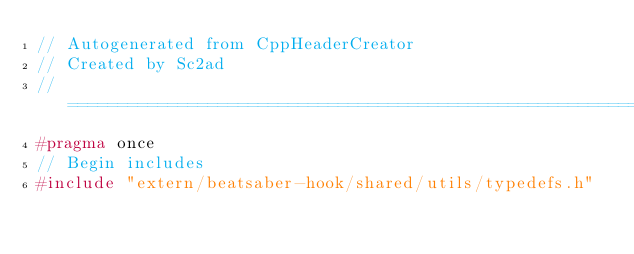<code> <loc_0><loc_0><loc_500><loc_500><_C++_>// Autogenerated from CppHeaderCreator
// Created by Sc2ad
// =========================================================================
#pragma once
// Begin includes
#include "extern/beatsaber-hook/shared/utils/typedefs.h"</code> 